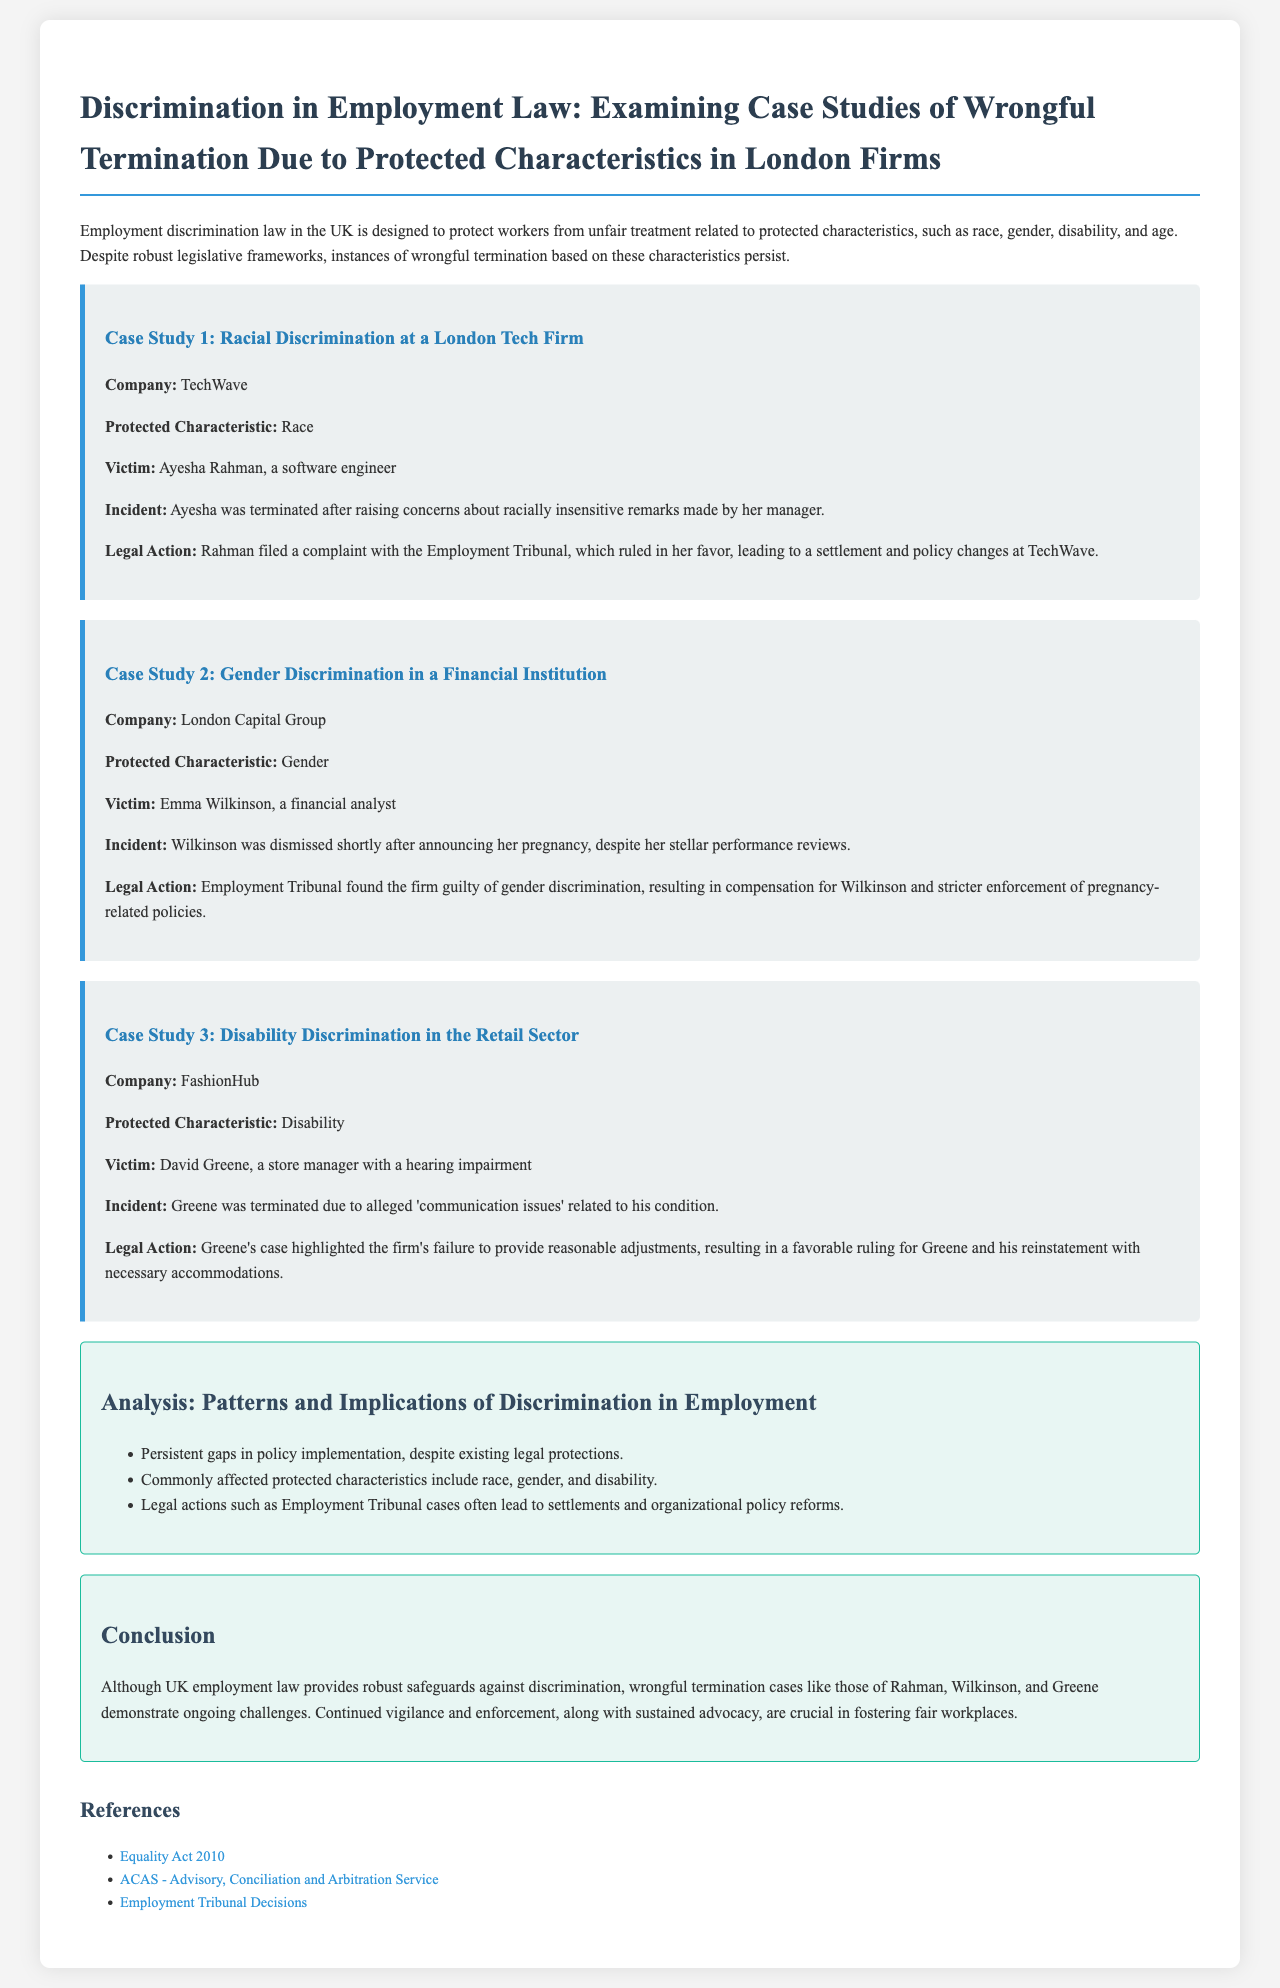What was the protected characteristic in Case Study 1? The protected characteristic in Case Study 1 pertains to race, specifically involving Ayesha Rahman.
Answer: Race Who was the victim in the gender discrimination case? The victim in the gender discrimination case was Emma Wilkinson.
Answer: Emma Wilkinson What legal action did Ayesha Rahman take? Ayesha Rahman filed a complaint with the Employment Tribunal regarding her wrongful termination.
Answer: Filed a complaint What company was found guilty of gender discrimination? The company found guilty of gender discrimination was London Capital Group.
Answer: London Capital Group Which protected characteristic was highlighted in Case Study 3? The protected characteristic highlighted in Case Study 3 was disability.
Answer: Disability What issue did David Greene face at FashionHub? David Greene faced termination due to alleged communication issues related to his hearing impairment.
Answer: Communication issues What overall pattern is noted in the analysis? The analysis notes that there are persistent gaps in policy implementation despite legal protections.
Answer: Gaps in policy implementation How did the Employment Tribunal rule in Emma Wilkinson's case? The Employment Tribunal found the firm guilty of gender discrimination in Emma Wilkinson's case.
Answer: Guilty 